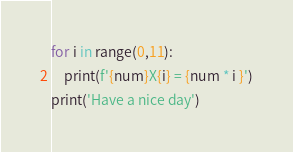Convert code to text. <code><loc_0><loc_0><loc_500><loc_500><_Python_>for i in range(0,11):
    print(f'{num}X{i} = {num * i }')
print('Have a nice day')</code> 